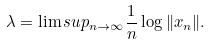Convert formula to latex. <formula><loc_0><loc_0><loc_500><loc_500>\lambda = \lim s u p _ { n \to \infty } \frac { 1 } { n } \log \| x _ { n } \| .</formula> 